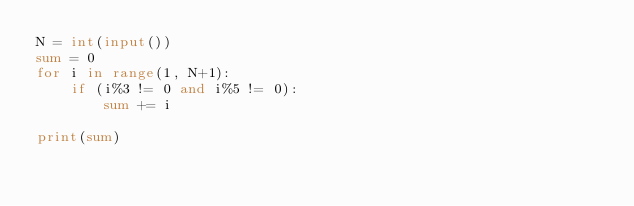<code> <loc_0><loc_0><loc_500><loc_500><_Python_>N = int(input())
sum = 0
for i in range(1, N+1):
    if (i%3 != 0 and i%5 != 0):
        sum += i

print(sum)</code> 